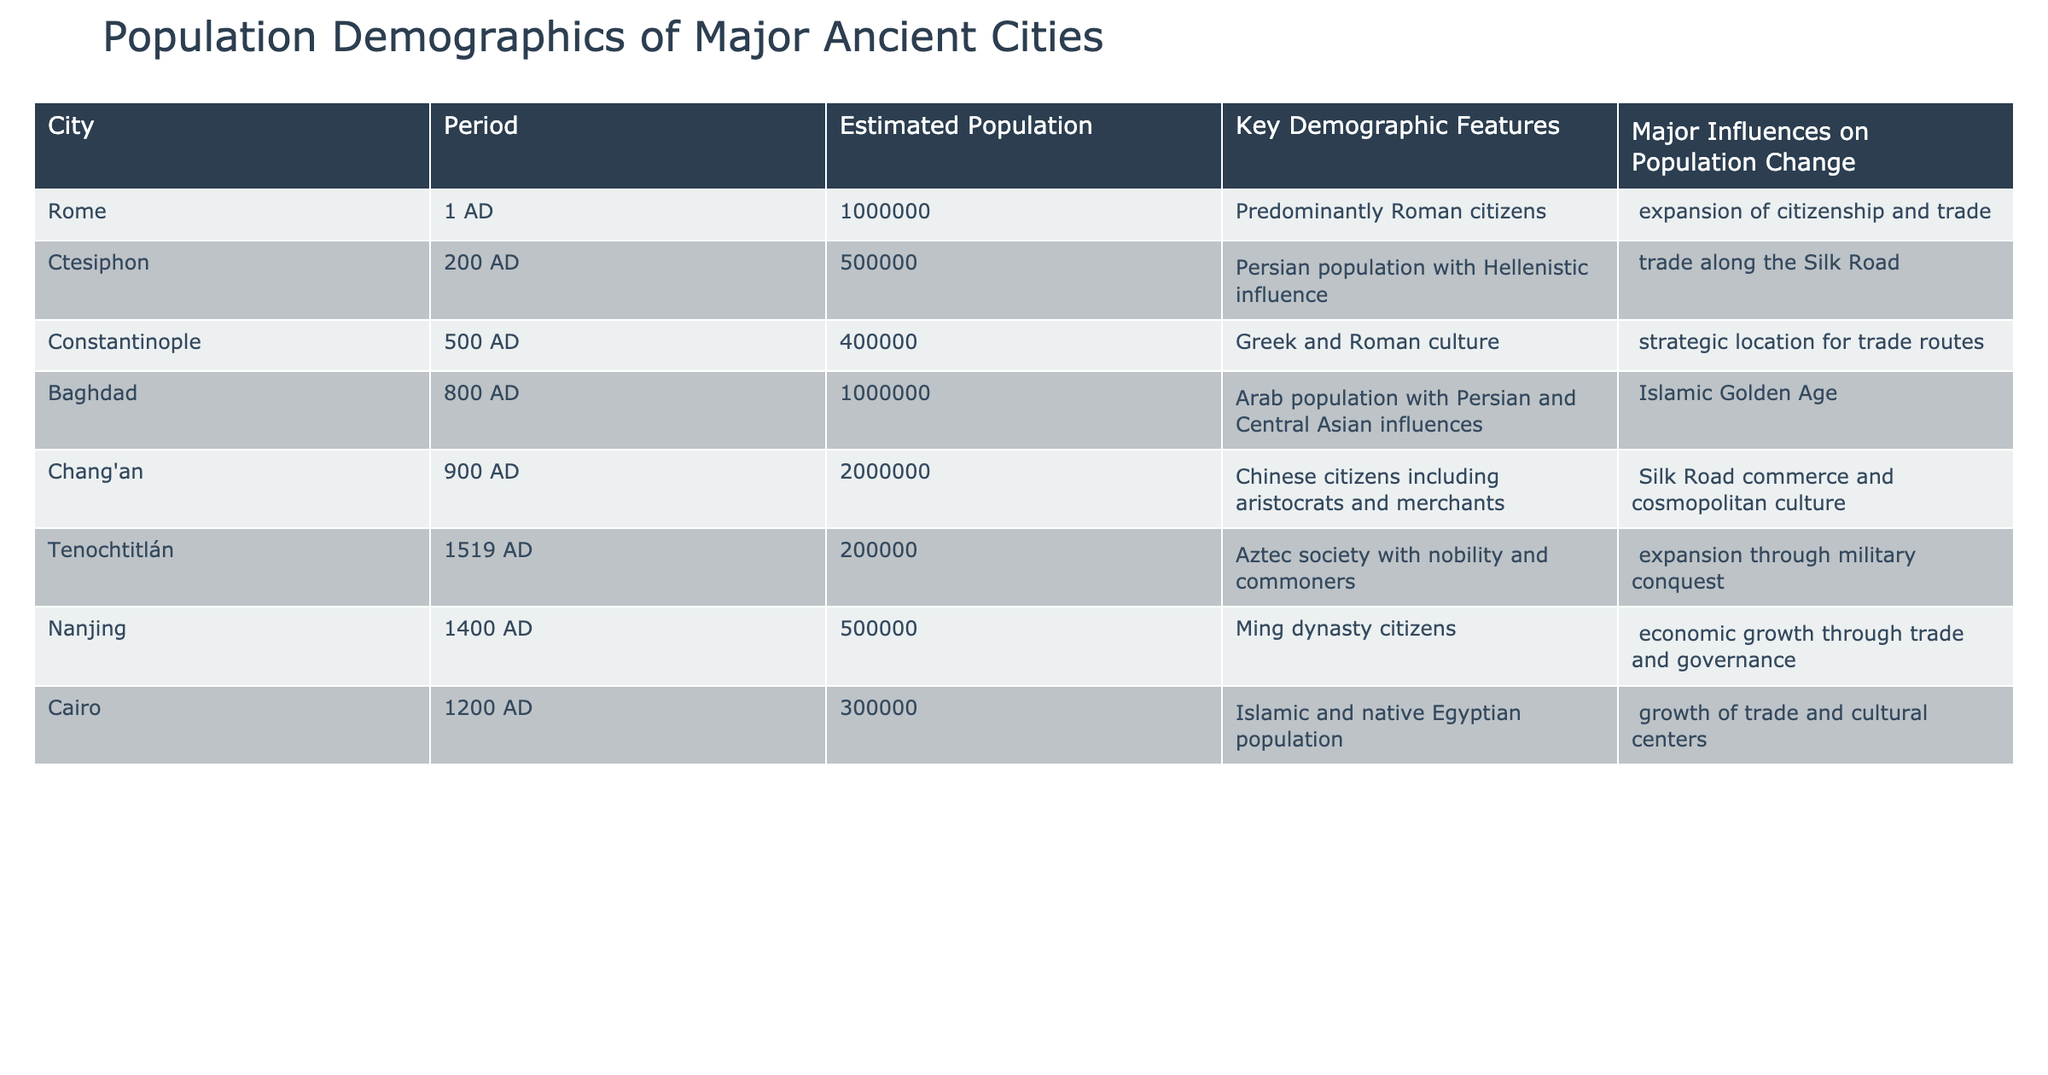What was the estimated population of Rome in 1 AD? The table states that the estimated population of Rome in 1 AD is 1,000,000.
Answer: 1,000,000 Which city had a population of 500,000 in 1400 AD? According to the table, Nanjing had an estimated population of 500,000 in 1400 AD.
Answer: Nanjing Is it true that Baghdad had an estimated population of 1,000,000 in 800 AD? Yes, the table indicates that Baghdad had an estimated population of 1,000,000 in 800 AD.
Answer: Yes What is the total estimated population of the cities in the 8th and 9th centuries (Baghdad and Chang'an)? The table lists Baghdad with a population of 1,000,000 in 800 AD and Chang'an with 2,000,000 in 900 AD. Adding those gives 1,000,000 + 2,000,000 = 3,000,000.
Answer: 3,000,000 Which city experienced population growth through military conquest according to the table? The table states that Tenochtitlán experienced expansion through military conquest, indicating its unique demographic dynamics.
Answer: Tenochtitlán What is the major influence on the population change in Ctesiphon during 200 AD? The table mentions that trade along the Silk Road was a key influence on the population change in Ctesiphon, contributing to its demographic features.
Answer: Trade along the Silk Road Was the major population of Constantinople in 500 AD primarily composed of Roman citizens? No, the key demographic features state it had Greek and Roman culture, but not predominantly Roman citizens.
Answer: No Which two cities had populations of over 1,000,000 and during which periods were they reported? The cities are Rome in 1 AD (1,000,000) and Chang'an in 900 AD (2,000,000). This involves referencing both cities and their respective populations in the provided years for accuracy.
Answer: Rome (1 AD) and Chang'an (900 AD) How much larger was the estimated population of Chang'an compared to Tenochtitlán? Chang'an had an estimated population of 2,000,000 in 900 AD, while Tenochtitlán had 200,000 in 1519 AD. The difference is 2,000,000 - 200,000 = 1,800,000, which quantifies the demographic gap between the two cities.
Answer: 1,800,000 